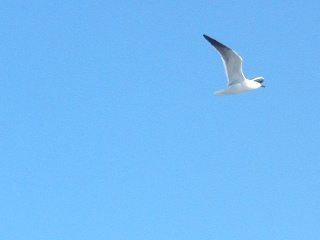Where is the bird? The bird is in the sky, flying freely against a backdrop of a cloudless blue expanse. 